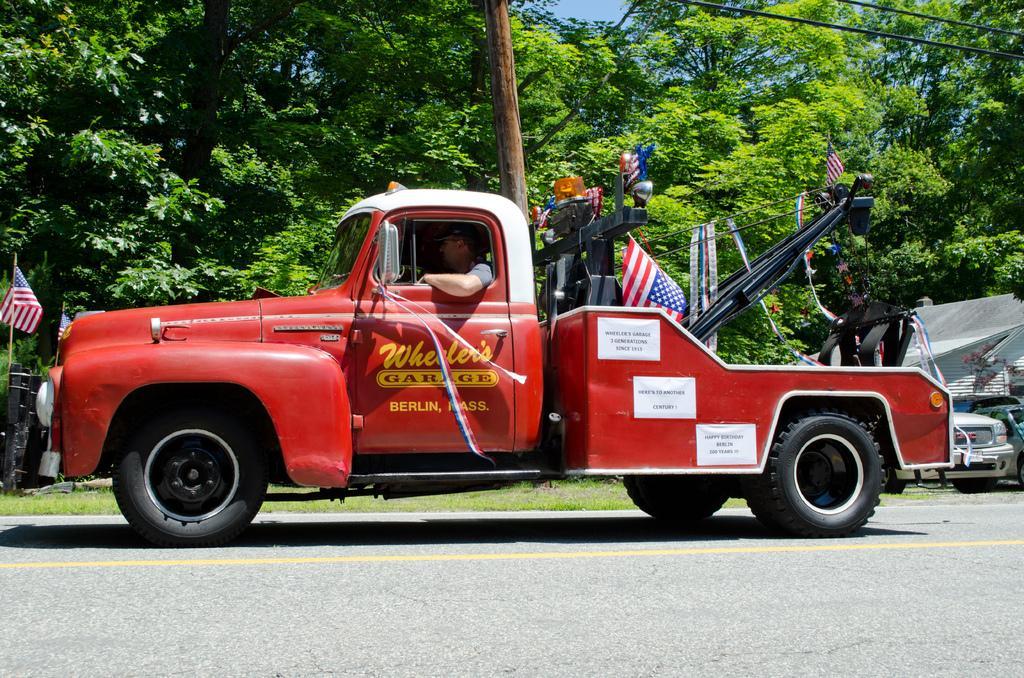Can you describe this image briefly? In this image there are vehicles, house, flags, trees, pole, road, grass, person and objects. Posters are on the vehicle. Person is sitting inside a vehicle. Through the trees the sky is visible. 